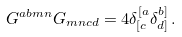<formula> <loc_0><loc_0><loc_500><loc_500>G ^ { a b m n } G _ { m n c d } = 4 \delta ^ { [ a } _ { [ c } \delta ^ { b ] } _ { d ] } \, .</formula> 